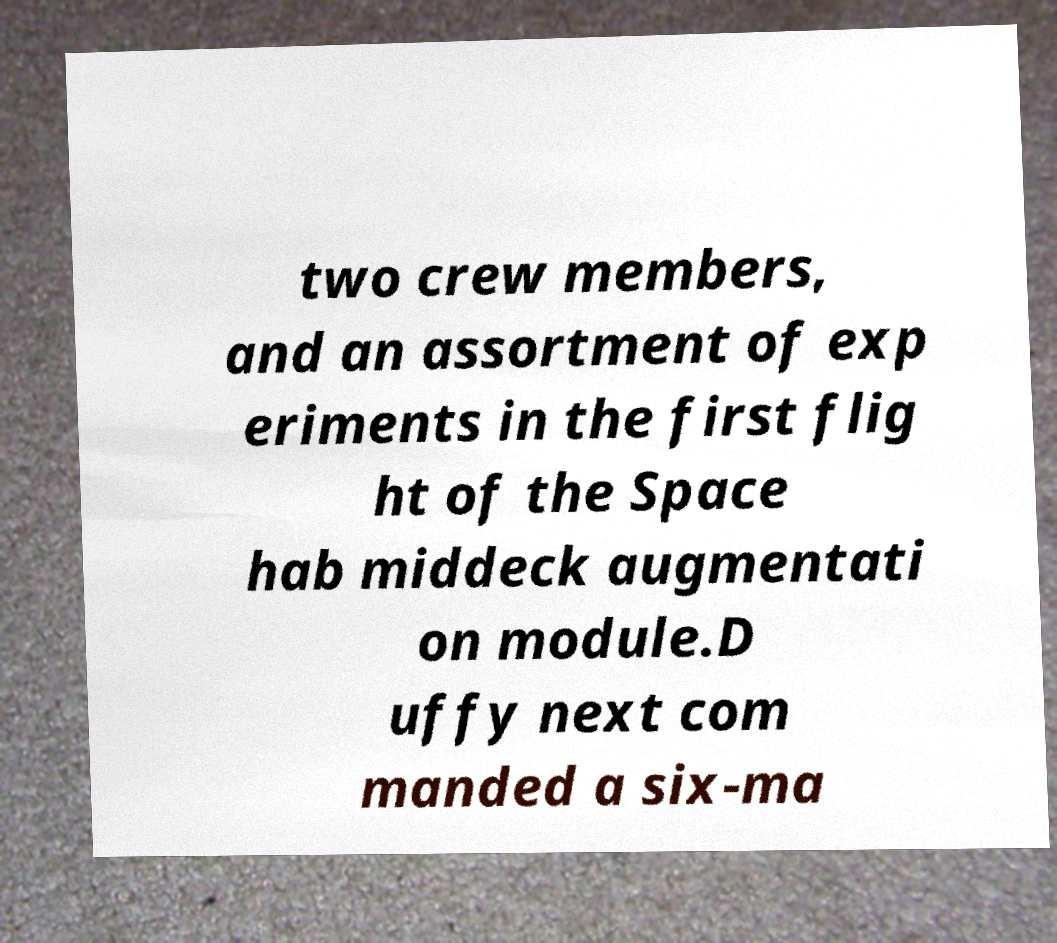What messages or text are displayed in this image? I need them in a readable, typed format. two crew members, and an assortment of exp eriments in the first flig ht of the Space hab middeck augmentati on module.D uffy next com manded a six-ma 